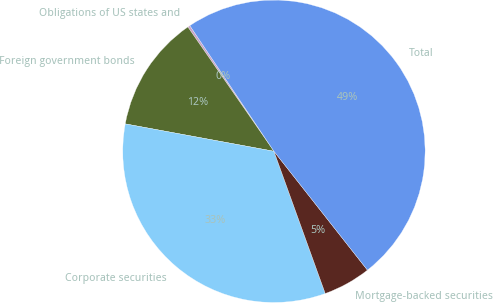Convert chart to OTSL. <chart><loc_0><loc_0><loc_500><loc_500><pie_chart><fcel>Obligations of US states and<fcel>Foreign government bonds<fcel>Corporate securities<fcel>Mortgage-backed securities<fcel>Total<nl><fcel>0.25%<fcel>12.46%<fcel>33.41%<fcel>5.1%<fcel>48.78%<nl></chart> 